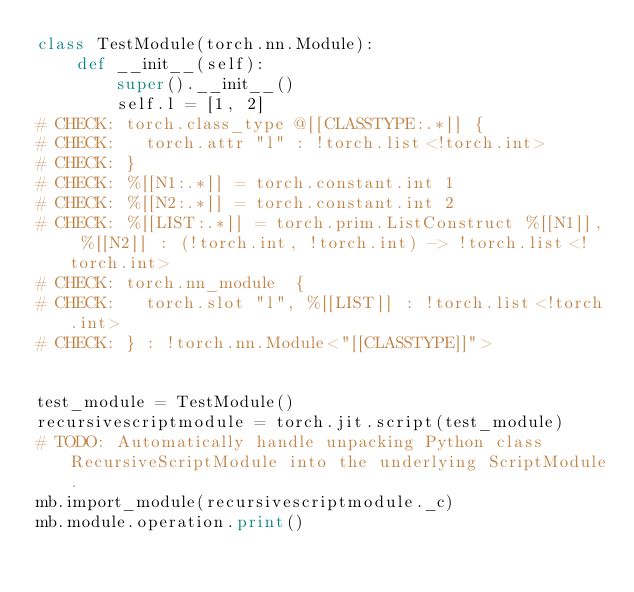Convert code to text. <code><loc_0><loc_0><loc_500><loc_500><_Python_>class TestModule(torch.nn.Module):
    def __init__(self):
        super().__init__()
        self.l = [1, 2]
# CHECK: torch.class_type @[[CLASSTYPE:.*]] {
# CHECK:   torch.attr "l" : !torch.list<!torch.int>
# CHECK: }
# CHECK: %[[N1:.*]] = torch.constant.int 1
# CHECK: %[[N2:.*]] = torch.constant.int 2
# CHECK: %[[LIST:.*]] = torch.prim.ListConstruct %[[N1]], %[[N2]] : (!torch.int, !torch.int) -> !torch.list<!torch.int>
# CHECK: torch.nn_module  {
# CHECK:   torch.slot "l", %[[LIST]] : !torch.list<!torch.int>
# CHECK: } : !torch.nn.Module<"[[CLASSTYPE]]">


test_module = TestModule()
recursivescriptmodule = torch.jit.script(test_module)
# TODO: Automatically handle unpacking Python class RecursiveScriptModule into the underlying ScriptModule.
mb.import_module(recursivescriptmodule._c)
mb.module.operation.print()
</code> 